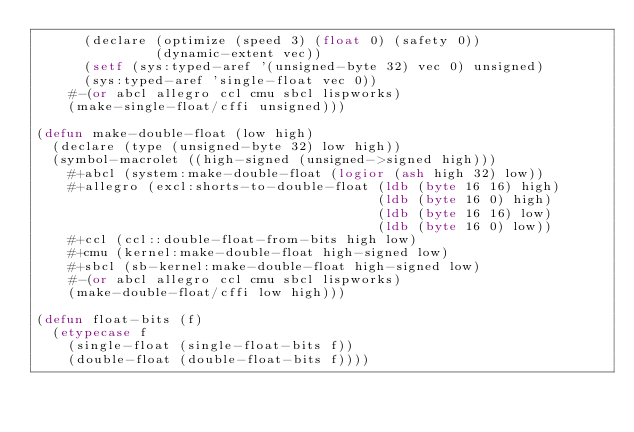<code> <loc_0><loc_0><loc_500><loc_500><_Lisp_>      (declare (optimize (speed 3) (float 0) (safety 0))
               (dynamic-extent vec))
      (setf (sys:typed-aref '(unsigned-byte 32) vec 0) unsigned)
      (sys:typed-aref 'single-float vec 0))
    #-(or abcl allegro ccl cmu sbcl lispworks)
    (make-single-float/cffi unsigned)))

(defun make-double-float (low high)
  (declare (type (unsigned-byte 32) low high))
  (symbol-macrolet ((high-signed (unsigned->signed high)))
    #+abcl (system:make-double-float (logior (ash high 32) low))
    #+allegro (excl:shorts-to-double-float (ldb (byte 16 16) high)
                                           (ldb (byte 16 0) high)
                                           (ldb (byte 16 16) low)
                                           (ldb (byte 16 0) low))
    #+ccl (ccl::double-float-from-bits high low)
    #+cmu (kernel:make-double-float high-signed low)
    #+sbcl (sb-kernel:make-double-float high-signed low)
    #-(or abcl allegro ccl cmu sbcl lispworks)
    (make-double-float/cffi low high)))

(defun float-bits (f)
  (etypecase f
    (single-float (single-float-bits f))
    (double-float (double-float-bits f))))
</code> 